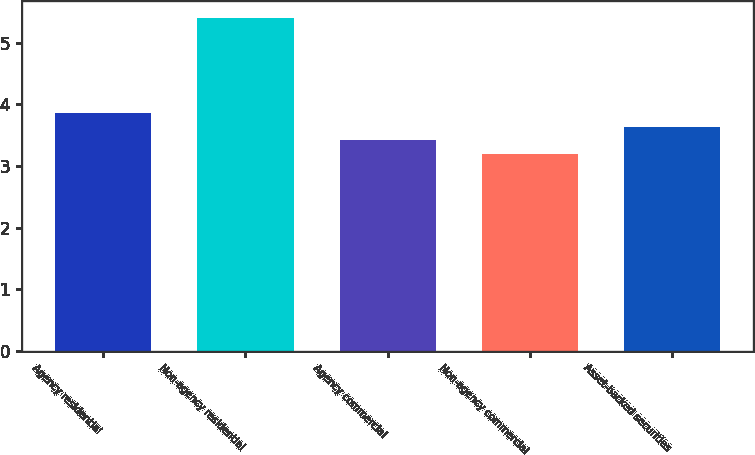<chart> <loc_0><loc_0><loc_500><loc_500><bar_chart><fcel>Agency residential<fcel>Non-agency residential<fcel>Agency commercial<fcel>Non-agency commercial<fcel>Asset-backed securities<nl><fcel>3.86<fcel>5.4<fcel>3.42<fcel>3.2<fcel>3.64<nl></chart> 